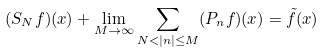Convert formula to latex. <formula><loc_0><loc_0><loc_500><loc_500>( S _ { N } { f } ) ( x ) + \lim _ { M \to \infty } \sum _ { N < | n | \leq M } ( P _ { n } { f } ) ( x ) = { \tilde { f } } ( x )</formula> 